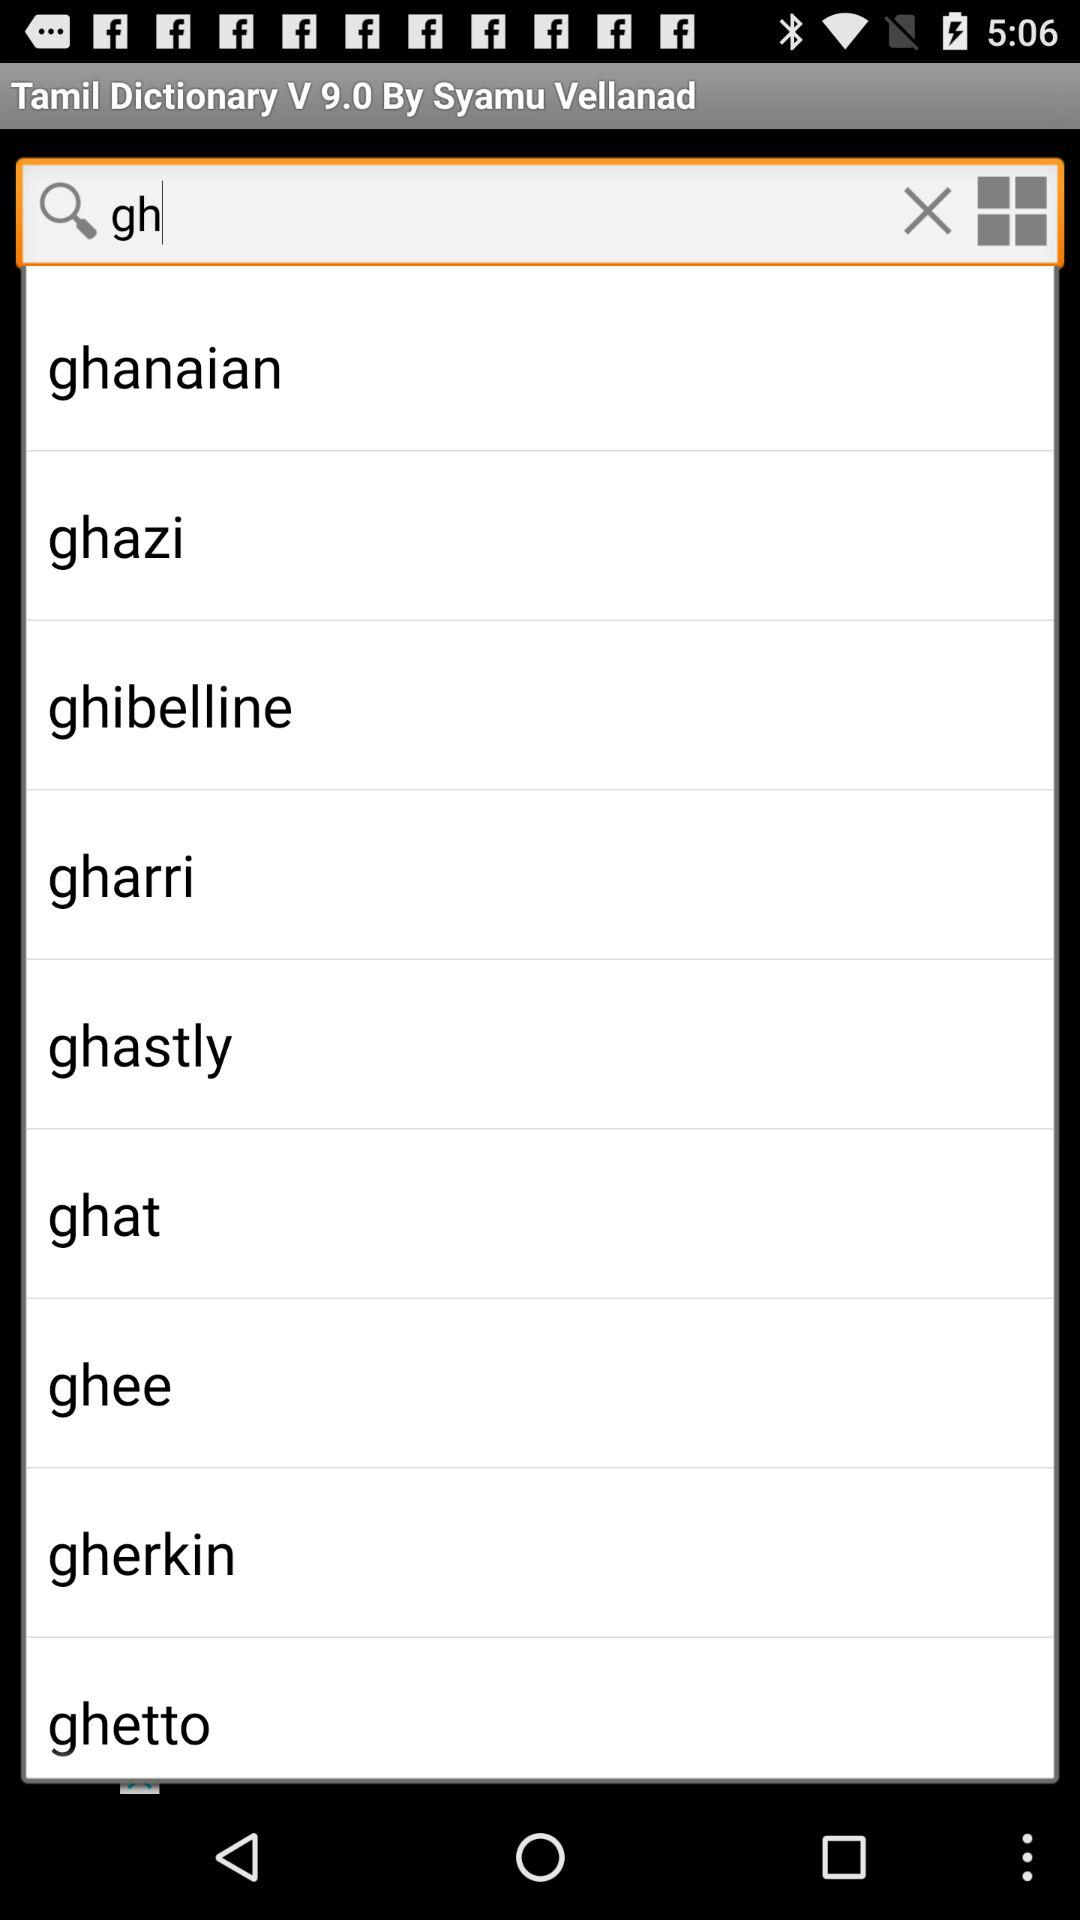Which is the version of the app? The version of the app is 9.0. 